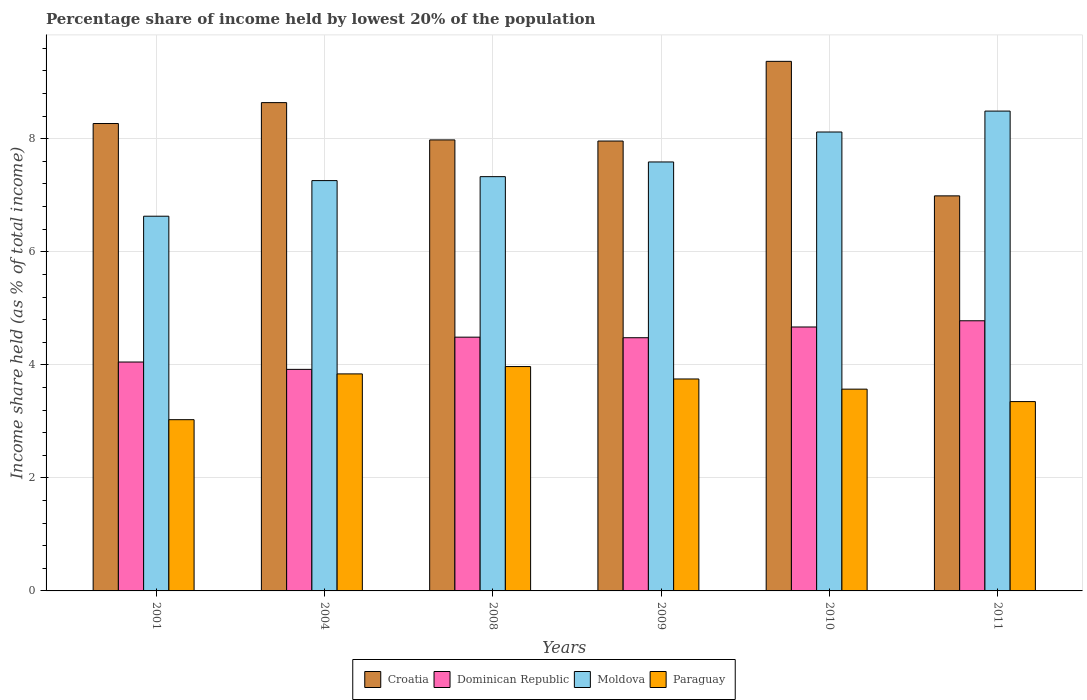How many different coloured bars are there?
Provide a succinct answer. 4. How many groups of bars are there?
Ensure brevity in your answer.  6. Are the number of bars per tick equal to the number of legend labels?
Offer a terse response. Yes. Are the number of bars on each tick of the X-axis equal?
Make the answer very short. Yes. How many bars are there on the 2nd tick from the right?
Keep it short and to the point. 4. In how many cases, is the number of bars for a given year not equal to the number of legend labels?
Your answer should be compact. 0. What is the percentage share of income held by lowest 20% of the population in Moldova in 2010?
Make the answer very short. 8.12. Across all years, what is the maximum percentage share of income held by lowest 20% of the population in Dominican Republic?
Offer a very short reply. 4.78. Across all years, what is the minimum percentage share of income held by lowest 20% of the population in Croatia?
Provide a succinct answer. 6.99. What is the total percentage share of income held by lowest 20% of the population in Moldova in the graph?
Give a very brief answer. 45.42. What is the difference between the percentage share of income held by lowest 20% of the population in Moldova in 2004 and that in 2009?
Provide a succinct answer. -0.33. What is the difference between the percentage share of income held by lowest 20% of the population in Paraguay in 2008 and the percentage share of income held by lowest 20% of the population in Moldova in 2009?
Offer a very short reply. -3.62. What is the average percentage share of income held by lowest 20% of the population in Croatia per year?
Offer a very short reply. 8.2. In the year 2010, what is the difference between the percentage share of income held by lowest 20% of the population in Dominican Republic and percentage share of income held by lowest 20% of the population in Moldova?
Offer a very short reply. -3.45. In how many years, is the percentage share of income held by lowest 20% of the population in Dominican Republic greater than 1.6 %?
Your answer should be compact. 6. What is the ratio of the percentage share of income held by lowest 20% of the population in Dominican Republic in 2009 to that in 2010?
Your answer should be compact. 0.96. What is the difference between the highest and the second highest percentage share of income held by lowest 20% of the population in Croatia?
Your answer should be compact. 0.73. What is the difference between the highest and the lowest percentage share of income held by lowest 20% of the population in Croatia?
Provide a short and direct response. 2.38. Is it the case that in every year, the sum of the percentage share of income held by lowest 20% of the population in Paraguay and percentage share of income held by lowest 20% of the population in Moldova is greater than the sum of percentage share of income held by lowest 20% of the population in Croatia and percentage share of income held by lowest 20% of the population in Dominican Republic?
Provide a short and direct response. No. What does the 3rd bar from the left in 2011 represents?
Make the answer very short. Moldova. What does the 3rd bar from the right in 2010 represents?
Provide a succinct answer. Dominican Republic. How many bars are there?
Make the answer very short. 24. Are the values on the major ticks of Y-axis written in scientific E-notation?
Make the answer very short. No. Does the graph contain any zero values?
Provide a short and direct response. No. Does the graph contain grids?
Your answer should be compact. Yes. Where does the legend appear in the graph?
Make the answer very short. Bottom center. How many legend labels are there?
Offer a terse response. 4. How are the legend labels stacked?
Give a very brief answer. Horizontal. What is the title of the graph?
Your answer should be very brief. Percentage share of income held by lowest 20% of the population. What is the label or title of the X-axis?
Ensure brevity in your answer.  Years. What is the label or title of the Y-axis?
Your answer should be compact. Income share held (as % of total income). What is the Income share held (as % of total income) in Croatia in 2001?
Give a very brief answer. 8.27. What is the Income share held (as % of total income) in Dominican Republic in 2001?
Make the answer very short. 4.05. What is the Income share held (as % of total income) of Moldova in 2001?
Offer a terse response. 6.63. What is the Income share held (as % of total income) of Paraguay in 2001?
Offer a very short reply. 3.03. What is the Income share held (as % of total income) of Croatia in 2004?
Your answer should be very brief. 8.64. What is the Income share held (as % of total income) in Dominican Republic in 2004?
Make the answer very short. 3.92. What is the Income share held (as % of total income) of Moldova in 2004?
Your response must be concise. 7.26. What is the Income share held (as % of total income) of Paraguay in 2004?
Provide a short and direct response. 3.84. What is the Income share held (as % of total income) of Croatia in 2008?
Provide a succinct answer. 7.98. What is the Income share held (as % of total income) of Dominican Republic in 2008?
Provide a succinct answer. 4.49. What is the Income share held (as % of total income) of Moldova in 2008?
Offer a terse response. 7.33. What is the Income share held (as % of total income) of Paraguay in 2008?
Give a very brief answer. 3.97. What is the Income share held (as % of total income) of Croatia in 2009?
Offer a terse response. 7.96. What is the Income share held (as % of total income) of Dominican Republic in 2009?
Ensure brevity in your answer.  4.48. What is the Income share held (as % of total income) of Moldova in 2009?
Your answer should be very brief. 7.59. What is the Income share held (as % of total income) in Paraguay in 2009?
Give a very brief answer. 3.75. What is the Income share held (as % of total income) in Croatia in 2010?
Provide a succinct answer. 9.37. What is the Income share held (as % of total income) of Dominican Republic in 2010?
Ensure brevity in your answer.  4.67. What is the Income share held (as % of total income) of Moldova in 2010?
Offer a terse response. 8.12. What is the Income share held (as % of total income) in Paraguay in 2010?
Give a very brief answer. 3.57. What is the Income share held (as % of total income) in Croatia in 2011?
Your answer should be very brief. 6.99. What is the Income share held (as % of total income) of Dominican Republic in 2011?
Your response must be concise. 4.78. What is the Income share held (as % of total income) of Moldova in 2011?
Your answer should be compact. 8.49. What is the Income share held (as % of total income) of Paraguay in 2011?
Ensure brevity in your answer.  3.35. Across all years, what is the maximum Income share held (as % of total income) in Croatia?
Give a very brief answer. 9.37. Across all years, what is the maximum Income share held (as % of total income) of Dominican Republic?
Give a very brief answer. 4.78. Across all years, what is the maximum Income share held (as % of total income) in Moldova?
Give a very brief answer. 8.49. Across all years, what is the maximum Income share held (as % of total income) in Paraguay?
Ensure brevity in your answer.  3.97. Across all years, what is the minimum Income share held (as % of total income) in Croatia?
Provide a succinct answer. 6.99. Across all years, what is the minimum Income share held (as % of total income) in Dominican Republic?
Keep it short and to the point. 3.92. Across all years, what is the minimum Income share held (as % of total income) in Moldova?
Your answer should be very brief. 6.63. Across all years, what is the minimum Income share held (as % of total income) of Paraguay?
Your answer should be very brief. 3.03. What is the total Income share held (as % of total income) of Croatia in the graph?
Provide a succinct answer. 49.21. What is the total Income share held (as % of total income) of Dominican Republic in the graph?
Provide a succinct answer. 26.39. What is the total Income share held (as % of total income) of Moldova in the graph?
Keep it short and to the point. 45.42. What is the total Income share held (as % of total income) of Paraguay in the graph?
Ensure brevity in your answer.  21.51. What is the difference between the Income share held (as % of total income) of Croatia in 2001 and that in 2004?
Ensure brevity in your answer.  -0.37. What is the difference between the Income share held (as % of total income) of Dominican Republic in 2001 and that in 2004?
Your response must be concise. 0.13. What is the difference between the Income share held (as % of total income) in Moldova in 2001 and that in 2004?
Offer a terse response. -0.63. What is the difference between the Income share held (as % of total income) in Paraguay in 2001 and that in 2004?
Ensure brevity in your answer.  -0.81. What is the difference between the Income share held (as % of total income) of Croatia in 2001 and that in 2008?
Your response must be concise. 0.29. What is the difference between the Income share held (as % of total income) of Dominican Republic in 2001 and that in 2008?
Make the answer very short. -0.44. What is the difference between the Income share held (as % of total income) in Moldova in 2001 and that in 2008?
Provide a short and direct response. -0.7. What is the difference between the Income share held (as % of total income) in Paraguay in 2001 and that in 2008?
Your response must be concise. -0.94. What is the difference between the Income share held (as % of total income) of Croatia in 2001 and that in 2009?
Your answer should be compact. 0.31. What is the difference between the Income share held (as % of total income) of Dominican Republic in 2001 and that in 2009?
Provide a succinct answer. -0.43. What is the difference between the Income share held (as % of total income) of Moldova in 2001 and that in 2009?
Your answer should be very brief. -0.96. What is the difference between the Income share held (as % of total income) of Paraguay in 2001 and that in 2009?
Ensure brevity in your answer.  -0.72. What is the difference between the Income share held (as % of total income) of Croatia in 2001 and that in 2010?
Your answer should be compact. -1.1. What is the difference between the Income share held (as % of total income) of Dominican Republic in 2001 and that in 2010?
Your answer should be compact. -0.62. What is the difference between the Income share held (as % of total income) of Moldova in 2001 and that in 2010?
Offer a very short reply. -1.49. What is the difference between the Income share held (as % of total income) in Paraguay in 2001 and that in 2010?
Give a very brief answer. -0.54. What is the difference between the Income share held (as % of total income) in Croatia in 2001 and that in 2011?
Provide a short and direct response. 1.28. What is the difference between the Income share held (as % of total income) of Dominican Republic in 2001 and that in 2011?
Make the answer very short. -0.73. What is the difference between the Income share held (as % of total income) of Moldova in 2001 and that in 2011?
Your answer should be very brief. -1.86. What is the difference between the Income share held (as % of total income) in Paraguay in 2001 and that in 2011?
Ensure brevity in your answer.  -0.32. What is the difference between the Income share held (as % of total income) of Croatia in 2004 and that in 2008?
Keep it short and to the point. 0.66. What is the difference between the Income share held (as % of total income) of Dominican Republic in 2004 and that in 2008?
Give a very brief answer. -0.57. What is the difference between the Income share held (as % of total income) of Moldova in 2004 and that in 2008?
Make the answer very short. -0.07. What is the difference between the Income share held (as % of total income) of Paraguay in 2004 and that in 2008?
Offer a very short reply. -0.13. What is the difference between the Income share held (as % of total income) of Croatia in 2004 and that in 2009?
Offer a terse response. 0.68. What is the difference between the Income share held (as % of total income) in Dominican Republic in 2004 and that in 2009?
Ensure brevity in your answer.  -0.56. What is the difference between the Income share held (as % of total income) of Moldova in 2004 and that in 2009?
Your response must be concise. -0.33. What is the difference between the Income share held (as % of total income) in Paraguay in 2004 and that in 2009?
Your answer should be compact. 0.09. What is the difference between the Income share held (as % of total income) of Croatia in 2004 and that in 2010?
Give a very brief answer. -0.73. What is the difference between the Income share held (as % of total income) in Dominican Republic in 2004 and that in 2010?
Offer a very short reply. -0.75. What is the difference between the Income share held (as % of total income) in Moldova in 2004 and that in 2010?
Your answer should be compact. -0.86. What is the difference between the Income share held (as % of total income) in Paraguay in 2004 and that in 2010?
Offer a terse response. 0.27. What is the difference between the Income share held (as % of total income) in Croatia in 2004 and that in 2011?
Keep it short and to the point. 1.65. What is the difference between the Income share held (as % of total income) of Dominican Republic in 2004 and that in 2011?
Make the answer very short. -0.86. What is the difference between the Income share held (as % of total income) of Moldova in 2004 and that in 2011?
Make the answer very short. -1.23. What is the difference between the Income share held (as % of total income) in Paraguay in 2004 and that in 2011?
Ensure brevity in your answer.  0.49. What is the difference between the Income share held (as % of total income) in Dominican Republic in 2008 and that in 2009?
Ensure brevity in your answer.  0.01. What is the difference between the Income share held (as % of total income) of Moldova in 2008 and that in 2009?
Your response must be concise. -0.26. What is the difference between the Income share held (as % of total income) in Paraguay in 2008 and that in 2009?
Ensure brevity in your answer.  0.22. What is the difference between the Income share held (as % of total income) in Croatia in 2008 and that in 2010?
Offer a very short reply. -1.39. What is the difference between the Income share held (as % of total income) in Dominican Republic in 2008 and that in 2010?
Your response must be concise. -0.18. What is the difference between the Income share held (as % of total income) of Moldova in 2008 and that in 2010?
Your answer should be compact. -0.79. What is the difference between the Income share held (as % of total income) of Paraguay in 2008 and that in 2010?
Offer a very short reply. 0.4. What is the difference between the Income share held (as % of total income) of Croatia in 2008 and that in 2011?
Your response must be concise. 0.99. What is the difference between the Income share held (as % of total income) of Dominican Republic in 2008 and that in 2011?
Provide a succinct answer. -0.29. What is the difference between the Income share held (as % of total income) in Moldova in 2008 and that in 2011?
Offer a very short reply. -1.16. What is the difference between the Income share held (as % of total income) of Paraguay in 2008 and that in 2011?
Make the answer very short. 0.62. What is the difference between the Income share held (as % of total income) of Croatia in 2009 and that in 2010?
Ensure brevity in your answer.  -1.41. What is the difference between the Income share held (as % of total income) in Dominican Republic in 2009 and that in 2010?
Keep it short and to the point. -0.19. What is the difference between the Income share held (as % of total income) in Moldova in 2009 and that in 2010?
Make the answer very short. -0.53. What is the difference between the Income share held (as % of total income) in Paraguay in 2009 and that in 2010?
Provide a short and direct response. 0.18. What is the difference between the Income share held (as % of total income) in Croatia in 2009 and that in 2011?
Keep it short and to the point. 0.97. What is the difference between the Income share held (as % of total income) of Dominican Republic in 2009 and that in 2011?
Ensure brevity in your answer.  -0.3. What is the difference between the Income share held (as % of total income) of Croatia in 2010 and that in 2011?
Your answer should be very brief. 2.38. What is the difference between the Income share held (as % of total income) of Dominican Republic in 2010 and that in 2011?
Your answer should be compact. -0.11. What is the difference between the Income share held (as % of total income) of Moldova in 2010 and that in 2011?
Give a very brief answer. -0.37. What is the difference between the Income share held (as % of total income) of Paraguay in 2010 and that in 2011?
Provide a succinct answer. 0.22. What is the difference between the Income share held (as % of total income) in Croatia in 2001 and the Income share held (as % of total income) in Dominican Republic in 2004?
Provide a succinct answer. 4.35. What is the difference between the Income share held (as % of total income) of Croatia in 2001 and the Income share held (as % of total income) of Moldova in 2004?
Offer a very short reply. 1.01. What is the difference between the Income share held (as % of total income) of Croatia in 2001 and the Income share held (as % of total income) of Paraguay in 2004?
Provide a short and direct response. 4.43. What is the difference between the Income share held (as % of total income) of Dominican Republic in 2001 and the Income share held (as % of total income) of Moldova in 2004?
Ensure brevity in your answer.  -3.21. What is the difference between the Income share held (as % of total income) of Dominican Republic in 2001 and the Income share held (as % of total income) of Paraguay in 2004?
Provide a short and direct response. 0.21. What is the difference between the Income share held (as % of total income) in Moldova in 2001 and the Income share held (as % of total income) in Paraguay in 2004?
Ensure brevity in your answer.  2.79. What is the difference between the Income share held (as % of total income) of Croatia in 2001 and the Income share held (as % of total income) of Dominican Republic in 2008?
Provide a succinct answer. 3.78. What is the difference between the Income share held (as % of total income) in Croatia in 2001 and the Income share held (as % of total income) in Paraguay in 2008?
Ensure brevity in your answer.  4.3. What is the difference between the Income share held (as % of total income) of Dominican Republic in 2001 and the Income share held (as % of total income) of Moldova in 2008?
Make the answer very short. -3.28. What is the difference between the Income share held (as % of total income) in Moldova in 2001 and the Income share held (as % of total income) in Paraguay in 2008?
Ensure brevity in your answer.  2.66. What is the difference between the Income share held (as % of total income) in Croatia in 2001 and the Income share held (as % of total income) in Dominican Republic in 2009?
Provide a succinct answer. 3.79. What is the difference between the Income share held (as % of total income) of Croatia in 2001 and the Income share held (as % of total income) of Moldova in 2009?
Your answer should be compact. 0.68. What is the difference between the Income share held (as % of total income) in Croatia in 2001 and the Income share held (as % of total income) in Paraguay in 2009?
Offer a very short reply. 4.52. What is the difference between the Income share held (as % of total income) in Dominican Republic in 2001 and the Income share held (as % of total income) in Moldova in 2009?
Your response must be concise. -3.54. What is the difference between the Income share held (as % of total income) of Dominican Republic in 2001 and the Income share held (as % of total income) of Paraguay in 2009?
Keep it short and to the point. 0.3. What is the difference between the Income share held (as % of total income) of Moldova in 2001 and the Income share held (as % of total income) of Paraguay in 2009?
Your answer should be compact. 2.88. What is the difference between the Income share held (as % of total income) of Dominican Republic in 2001 and the Income share held (as % of total income) of Moldova in 2010?
Ensure brevity in your answer.  -4.07. What is the difference between the Income share held (as % of total income) of Dominican Republic in 2001 and the Income share held (as % of total income) of Paraguay in 2010?
Give a very brief answer. 0.48. What is the difference between the Income share held (as % of total income) of Moldova in 2001 and the Income share held (as % of total income) of Paraguay in 2010?
Offer a terse response. 3.06. What is the difference between the Income share held (as % of total income) of Croatia in 2001 and the Income share held (as % of total income) of Dominican Republic in 2011?
Your answer should be very brief. 3.49. What is the difference between the Income share held (as % of total income) in Croatia in 2001 and the Income share held (as % of total income) in Moldova in 2011?
Give a very brief answer. -0.22. What is the difference between the Income share held (as % of total income) in Croatia in 2001 and the Income share held (as % of total income) in Paraguay in 2011?
Provide a succinct answer. 4.92. What is the difference between the Income share held (as % of total income) in Dominican Republic in 2001 and the Income share held (as % of total income) in Moldova in 2011?
Keep it short and to the point. -4.44. What is the difference between the Income share held (as % of total income) of Moldova in 2001 and the Income share held (as % of total income) of Paraguay in 2011?
Your answer should be very brief. 3.28. What is the difference between the Income share held (as % of total income) in Croatia in 2004 and the Income share held (as % of total income) in Dominican Republic in 2008?
Keep it short and to the point. 4.15. What is the difference between the Income share held (as % of total income) of Croatia in 2004 and the Income share held (as % of total income) of Moldova in 2008?
Your answer should be very brief. 1.31. What is the difference between the Income share held (as % of total income) in Croatia in 2004 and the Income share held (as % of total income) in Paraguay in 2008?
Your answer should be compact. 4.67. What is the difference between the Income share held (as % of total income) of Dominican Republic in 2004 and the Income share held (as % of total income) of Moldova in 2008?
Offer a very short reply. -3.41. What is the difference between the Income share held (as % of total income) in Dominican Republic in 2004 and the Income share held (as % of total income) in Paraguay in 2008?
Provide a short and direct response. -0.05. What is the difference between the Income share held (as % of total income) in Moldova in 2004 and the Income share held (as % of total income) in Paraguay in 2008?
Provide a succinct answer. 3.29. What is the difference between the Income share held (as % of total income) of Croatia in 2004 and the Income share held (as % of total income) of Dominican Republic in 2009?
Keep it short and to the point. 4.16. What is the difference between the Income share held (as % of total income) of Croatia in 2004 and the Income share held (as % of total income) of Moldova in 2009?
Make the answer very short. 1.05. What is the difference between the Income share held (as % of total income) in Croatia in 2004 and the Income share held (as % of total income) in Paraguay in 2009?
Ensure brevity in your answer.  4.89. What is the difference between the Income share held (as % of total income) of Dominican Republic in 2004 and the Income share held (as % of total income) of Moldova in 2009?
Offer a very short reply. -3.67. What is the difference between the Income share held (as % of total income) of Dominican Republic in 2004 and the Income share held (as % of total income) of Paraguay in 2009?
Make the answer very short. 0.17. What is the difference between the Income share held (as % of total income) in Moldova in 2004 and the Income share held (as % of total income) in Paraguay in 2009?
Ensure brevity in your answer.  3.51. What is the difference between the Income share held (as % of total income) of Croatia in 2004 and the Income share held (as % of total income) of Dominican Republic in 2010?
Give a very brief answer. 3.97. What is the difference between the Income share held (as % of total income) of Croatia in 2004 and the Income share held (as % of total income) of Moldova in 2010?
Your answer should be compact. 0.52. What is the difference between the Income share held (as % of total income) of Croatia in 2004 and the Income share held (as % of total income) of Paraguay in 2010?
Your response must be concise. 5.07. What is the difference between the Income share held (as % of total income) of Dominican Republic in 2004 and the Income share held (as % of total income) of Moldova in 2010?
Offer a very short reply. -4.2. What is the difference between the Income share held (as % of total income) of Moldova in 2004 and the Income share held (as % of total income) of Paraguay in 2010?
Give a very brief answer. 3.69. What is the difference between the Income share held (as % of total income) in Croatia in 2004 and the Income share held (as % of total income) in Dominican Republic in 2011?
Your answer should be compact. 3.86. What is the difference between the Income share held (as % of total income) in Croatia in 2004 and the Income share held (as % of total income) in Paraguay in 2011?
Your answer should be compact. 5.29. What is the difference between the Income share held (as % of total income) in Dominican Republic in 2004 and the Income share held (as % of total income) in Moldova in 2011?
Give a very brief answer. -4.57. What is the difference between the Income share held (as % of total income) in Dominican Republic in 2004 and the Income share held (as % of total income) in Paraguay in 2011?
Make the answer very short. 0.57. What is the difference between the Income share held (as % of total income) in Moldova in 2004 and the Income share held (as % of total income) in Paraguay in 2011?
Provide a short and direct response. 3.91. What is the difference between the Income share held (as % of total income) in Croatia in 2008 and the Income share held (as % of total income) in Dominican Republic in 2009?
Provide a succinct answer. 3.5. What is the difference between the Income share held (as % of total income) of Croatia in 2008 and the Income share held (as % of total income) of Moldova in 2009?
Your answer should be compact. 0.39. What is the difference between the Income share held (as % of total income) of Croatia in 2008 and the Income share held (as % of total income) of Paraguay in 2009?
Make the answer very short. 4.23. What is the difference between the Income share held (as % of total income) of Dominican Republic in 2008 and the Income share held (as % of total income) of Paraguay in 2009?
Make the answer very short. 0.74. What is the difference between the Income share held (as % of total income) in Moldova in 2008 and the Income share held (as % of total income) in Paraguay in 2009?
Offer a terse response. 3.58. What is the difference between the Income share held (as % of total income) of Croatia in 2008 and the Income share held (as % of total income) of Dominican Republic in 2010?
Keep it short and to the point. 3.31. What is the difference between the Income share held (as % of total income) in Croatia in 2008 and the Income share held (as % of total income) in Moldova in 2010?
Make the answer very short. -0.14. What is the difference between the Income share held (as % of total income) in Croatia in 2008 and the Income share held (as % of total income) in Paraguay in 2010?
Make the answer very short. 4.41. What is the difference between the Income share held (as % of total income) of Dominican Republic in 2008 and the Income share held (as % of total income) of Moldova in 2010?
Offer a very short reply. -3.63. What is the difference between the Income share held (as % of total income) in Moldova in 2008 and the Income share held (as % of total income) in Paraguay in 2010?
Make the answer very short. 3.76. What is the difference between the Income share held (as % of total income) of Croatia in 2008 and the Income share held (as % of total income) of Dominican Republic in 2011?
Offer a very short reply. 3.2. What is the difference between the Income share held (as % of total income) in Croatia in 2008 and the Income share held (as % of total income) in Moldova in 2011?
Make the answer very short. -0.51. What is the difference between the Income share held (as % of total income) in Croatia in 2008 and the Income share held (as % of total income) in Paraguay in 2011?
Your response must be concise. 4.63. What is the difference between the Income share held (as % of total income) of Dominican Republic in 2008 and the Income share held (as % of total income) of Paraguay in 2011?
Make the answer very short. 1.14. What is the difference between the Income share held (as % of total income) of Moldova in 2008 and the Income share held (as % of total income) of Paraguay in 2011?
Provide a succinct answer. 3.98. What is the difference between the Income share held (as % of total income) in Croatia in 2009 and the Income share held (as % of total income) in Dominican Republic in 2010?
Your answer should be very brief. 3.29. What is the difference between the Income share held (as % of total income) in Croatia in 2009 and the Income share held (as % of total income) in Moldova in 2010?
Your response must be concise. -0.16. What is the difference between the Income share held (as % of total income) of Croatia in 2009 and the Income share held (as % of total income) of Paraguay in 2010?
Your answer should be very brief. 4.39. What is the difference between the Income share held (as % of total income) in Dominican Republic in 2009 and the Income share held (as % of total income) in Moldova in 2010?
Make the answer very short. -3.64. What is the difference between the Income share held (as % of total income) in Dominican Republic in 2009 and the Income share held (as % of total income) in Paraguay in 2010?
Keep it short and to the point. 0.91. What is the difference between the Income share held (as % of total income) in Moldova in 2009 and the Income share held (as % of total income) in Paraguay in 2010?
Offer a terse response. 4.02. What is the difference between the Income share held (as % of total income) in Croatia in 2009 and the Income share held (as % of total income) in Dominican Republic in 2011?
Your answer should be compact. 3.18. What is the difference between the Income share held (as % of total income) of Croatia in 2009 and the Income share held (as % of total income) of Moldova in 2011?
Offer a very short reply. -0.53. What is the difference between the Income share held (as % of total income) of Croatia in 2009 and the Income share held (as % of total income) of Paraguay in 2011?
Your answer should be compact. 4.61. What is the difference between the Income share held (as % of total income) in Dominican Republic in 2009 and the Income share held (as % of total income) in Moldova in 2011?
Make the answer very short. -4.01. What is the difference between the Income share held (as % of total income) in Dominican Republic in 2009 and the Income share held (as % of total income) in Paraguay in 2011?
Provide a succinct answer. 1.13. What is the difference between the Income share held (as % of total income) of Moldova in 2009 and the Income share held (as % of total income) of Paraguay in 2011?
Give a very brief answer. 4.24. What is the difference between the Income share held (as % of total income) in Croatia in 2010 and the Income share held (as % of total income) in Dominican Republic in 2011?
Offer a very short reply. 4.59. What is the difference between the Income share held (as % of total income) in Croatia in 2010 and the Income share held (as % of total income) in Moldova in 2011?
Provide a short and direct response. 0.88. What is the difference between the Income share held (as % of total income) of Croatia in 2010 and the Income share held (as % of total income) of Paraguay in 2011?
Keep it short and to the point. 6.02. What is the difference between the Income share held (as % of total income) of Dominican Republic in 2010 and the Income share held (as % of total income) of Moldova in 2011?
Provide a short and direct response. -3.82. What is the difference between the Income share held (as % of total income) of Dominican Republic in 2010 and the Income share held (as % of total income) of Paraguay in 2011?
Offer a terse response. 1.32. What is the difference between the Income share held (as % of total income) of Moldova in 2010 and the Income share held (as % of total income) of Paraguay in 2011?
Offer a very short reply. 4.77. What is the average Income share held (as % of total income) of Croatia per year?
Keep it short and to the point. 8.2. What is the average Income share held (as % of total income) in Dominican Republic per year?
Ensure brevity in your answer.  4.4. What is the average Income share held (as % of total income) of Moldova per year?
Offer a terse response. 7.57. What is the average Income share held (as % of total income) in Paraguay per year?
Make the answer very short. 3.58. In the year 2001, what is the difference between the Income share held (as % of total income) in Croatia and Income share held (as % of total income) in Dominican Republic?
Make the answer very short. 4.22. In the year 2001, what is the difference between the Income share held (as % of total income) of Croatia and Income share held (as % of total income) of Moldova?
Keep it short and to the point. 1.64. In the year 2001, what is the difference between the Income share held (as % of total income) of Croatia and Income share held (as % of total income) of Paraguay?
Offer a very short reply. 5.24. In the year 2001, what is the difference between the Income share held (as % of total income) of Dominican Republic and Income share held (as % of total income) of Moldova?
Your response must be concise. -2.58. In the year 2001, what is the difference between the Income share held (as % of total income) in Dominican Republic and Income share held (as % of total income) in Paraguay?
Provide a succinct answer. 1.02. In the year 2001, what is the difference between the Income share held (as % of total income) in Moldova and Income share held (as % of total income) in Paraguay?
Provide a succinct answer. 3.6. In the year 2004, what is the difference between the Income share held (as % of total income) of Croatia and Income share held (as % of total income) of Dominican Republic?
Keep it short and to the point. 4.72. In the year 2004, what is the difference between the Income share held (as % of total income) in Croatia and Income share held (as % of total income) in Moldova?
Provide a short and direct response. 1.38. In the year 2004, what is the difference between the Income share held (as % of total income) of Dominican Republic and Income share held (as % of total income) of Moldova?
Keep it short and to the point. -3.34. In the year 2004, what is the difference between the Income share held (as % of total income) of Dominican Republic and Income share held (as % of total income) of Paraguay?
Offer a terse response. 0.08. In the year 2004, what is the difference between the Income share held (as % of total income) in Moldova and Income share held (as % of total income) in Paraguay?
Your answer should be compact. 3.42. In the year 2008, what is the difference between the Income share held (as % of total income) in Croatia and Income share held (as % of total income) in Dominican Republic?
Offer a terse response. 3.49. In the year 2008, what is the difference between the Income share held (as % of total income) in Croatia and Income share held (as % of total income) in Moldova?
Ensure brevity in your answer.  0.65. In the year 2008, what is the difference between the Income share held (as % of total income) in Croatia and Income share held (as % of total income) in Paraguay?
Ensure brevity in your answer.  4.01. In the year 2008, what is the difference between the Income share held (as % of total income) of Dominican Republic and Income share held (as % of total income) of Moldova?
Offer a very short reply. -2.84. In the year 2008, what is the difference between the Income share held (as % of total income) of Dominican Republic and Income share held (as % of total income) of Paraguay?
Provide a short and direct response. 0.52. In the year 2008, what is the difference between the Income share held (as % of total income) in Moldova and Income share held (as % of total income) in Paraguay?
Make the answer very short. 3.36. In the year 2009, what is the difference between the Income share held (as % of total income) in Croatia and Income share held (as % of total income) in Dominican Republic?
Offer a very short reply. 3.48. In the year 2009, what is the difference between the Income share held (as % of total income) of Croatia and Income share held (as % of total income) of Moldova?
Your answer should be compact. 0.37. In the year 2009, what is the difference between the Income share held (as % of total income) of Croatia and Income share held (as % of total income) of Paraguay?
Offer a terse response. 4.21. In the year 2009, what is the difference between the Income share held (as % of total income) of Dominican Republic and Income share held (as % of total income) of Moldova?
Provide a succinct answer. -3.11. In the year 2009, what is the difference between the Income share held (as % of total income) of Dominican Republic and Income share held (as % of total income) of Paraguay?
Your response must be concise. 0.73. In the year 2009, what is the difference between the Income share held (as % of total income) in Moldova and Income share held (as % of total income) in Paraguay?
Offer a terse response. 3.84. In the year 2010, what is the difference between the Income share held (as % of total income) of Croatia and Income share held (as % of total income) of Dominican Republic?
Provide a succinct answer. 4.7. In the year 2010, what is the difference between the Income share held (as % of total income) in Croatia and Income share held (as % of total income) in Moldova?
Your answer should be compact. 1.25. In the year 2010, what is the difference between the Income share held (as % of total income) of Croatia and Income share held (as % of total income) of Paraguay?
Ensure brevity in your answer.  5.8. In the year 2010, what is the difference between the Income share held (as % of total income) of Dominican Republic and Income share held (as % of total income) of Moldova?
Keep it short and to the point. -3.45. In the year 2010, what is the difference between the Income share held (as % of total income) of Dominican Republic and Income share held (as % of total income) of Paraguay?
Make the answer very short. 1.1. In the year 2010, what is the difference between the Income share held (as % of total income) of Moldova and Income share held (as % of total income) of Paraguay?
Give a very brief answer. 4.55. In the year 2011, what is the difference between the Income share held (as % of total income) in Croatia and Income share held (as % of total income) in Dominican Republic?
Keep it short and to the point. 2.21. In the year 2011, what is the difference between the Income share held (as % of total income) in Croatia and Income share held (as % of total income) in Moldova?
Make the answer very short. -1.5. In the year 2011, what is the difference between the Income share held (as % of total income) in Croatia and Income share held (as % of total income) in Paraguay?
Offer a terse response. 3.64. In the year 2011, what is the difference between the Income share held (as % of total income) of Dominican Republic and Income share held (as % of total income) of Moldova?
Your answer should be compact. -3.71. In the year 2011, what is the difference between the Income share held (as % of total income) of Dominican Republic and Income share held (as % of total income) of Paraguay?
Provide a succinct answer. 1.43. In the year 2011, what is the difference between the Income share held (as % of total income) in Moldova and Income share held (as % of total income) in Paraguay?
Make the answer very short. 5.14. What is the ratio of the Income share held (as % of total income) in Croatia in 2001 to that in 2004?
Give a very brief answer. 0.96. What is the ratio of the Income share held (as % of total income) in Dominican Republic in 2001 to that in 2004?
Your answer should be very brief. 1.03. What is the ratio of the Income share held (as % of total income) of Moldova in 2001 to that in 2004?
Your answer should be compact. 0.91. What is the ratio of the Income share held (as % of total income) of Paraguay in 2001 to that in 2004?
Keep it short and to the point. 0.79. What is the ratio of the Income share held (as % of total income) in Croatia in 2001 to that in 2008?
Make the answer very short. 1.04. What is the ratio of the Income share held (as % of total income) of Dominican Republic in 2001 to that in 2008?
Your answer should be very brief. 0.9. What is the ratio of the Income share held (as % of total income) in Moldova in 2001 to that in 2008?
Keep it short and to the point. 0.9. What is the ratio of the Income share held (as % of total income) of Paraguay in 2001 to that in 2008?
Your response must be concise. 0.76. What is the ratio of the Income share held (as % of total income) in Croatia in 2001 to that in 2009?
Make the answer very short. 1.04. What is the ratio of the Income share held (as % of total income) in Dominican Republic in 2001 to that in 2009?
Your answer should be very brief. 0.9. What is the ratio of the Income share held (as % of total income) in Moldova in 2001 to that in 2009?
Your answer should be compact. 0.87. What is the ratio of the Income share held (as % of total income) in Paraguay in 2001 to that in 2009?
Your answer should be compact. 0.81. What is the ratio of the Income share held (as % of total income) of Croatia in 2001 to that in 2010?
Provide a succinct answer. 0.88. What is the ratio of the Income share held (as % of total income) in Dominican Republic in 2001 to that in 2010?
Provide a short and direct response. 0.87. What is the ratio of the Income share held (as % of total income) of Moldova in 2001 to that in 2010?
Provide a short and direct response. 0.82. What is the ratio of the Income share held (as % of total income) in Paraguay in 2001 to that in 2010?
Your answer should be very brief. 0.85. What is the ratio of the Income share held (as % of total income) in Croatia in 2001 to that in 2011?
Make the answer very short. 1.18. What is the ratio of the Income share held (as % of total income) in Dominican Republic in 2001 to that in 2011?
Give a very brief answer. 0.85. What is the ratio of the Income share held (as % of total income) in Moldova in 2001 to that in 2011?
Offer a very short reply. 0.78. What is the ratio of the Income share held (as % of total income) of Paraguay in 2001 to that in 2011?
Offer a terse response. 0.9. What is the ratio of the Income share held (as % of total income) in Croatia in 2004 to that in 2008?
Provide a short and direct response. 1.08. What is the ratio of the Income share held (as % of total income) of Dominican Republic in 2004 to that in 2008?
Provide a succinct answer. 0.87. What is the ratio of the Income share held (as % of total income) of Moldova in 2004 to that in 2008?
Your response must be concise. 0.99. What is the ratio of the Income share held (as % of total income) of Paraguay in 2004 to that in 2008?
Ensure brevity in your answer.  0.97. What is the ratio of the Income share held (as % of total income) in Croatia in 2004 to that in 2009?
Your answer should be compact. 1.09. What is the ratio of the Income share held (as % of total income) in Moldova in 2004 to that in 2009?
Offer a very short reply. 0.96. What is the ratio of the Income share held (as % of total income) in Croatia in 2004 to that in 2010?
Your response must be concise. 0.92. What is the ratio of the Income share held (as % of total income) of Dominican Republic in 2004 to that in 2010?
Make the answer very short. 0.84. What is the ratio of the Income share held (as % of total income) in Moldova in 2004 to that in 2010?
Keep it short and to the point. 0.89. What is the ratio of the Income share held (as % of total income) of Paraguay in 2004 to that in 2010?
Provide a succinct answer. 1.08. What is the ratio of the Income share held (as % of total income) in Croatia in 2004 to that in 2011?
Make the answer very short. 1.24. What is the ratio of the Income share held (as % of total income) of Dominican Republic in 2004 to that in 2011?
Ensure brevity in your answer.  0.82. What is the ratio of the Income share held (as % of total income) in Moldova in 2004 to that in 2011?
Give a very brief answer. 0.86. What is the ratio of the Income share held (as % of total income) in Paraguay in 2004 to that in 2011?
Give a very brief answer. 1.15. What is the ratio of the Income share held (as % of total income) of Croatia in 2008 to that in 2009?
Offer a terse response. 1. What is the ratio of the Income share held (as % of total income) in Dominican Republic in 2008 to that in 2009?
Your response must be concise. 1. What is the ratio of the Income share held (as % of total income) in Moldova in 2008 to that in 2009?
Provide a short and direct response. 0.97. What is the ratio of the Income share held (as % of total income) of Paraguay in 2008 to that in 2009?
Ensure brevity in your answer.  1.06. What is the ratio of the Income share held (as % of total income) in Croatia in 2008 to that in 2010?
Keep it short and to the point. 0.85. What is the ratio of the Income share held (as % of total income) in Dominican Republic in 2008 to that in 2010?
Keep it short and to the point. 0.96. What is the ratio of the Income share held (as % of total income) in Moldova in 2008 to that in 2010?
Ensure brevity in your answer.  0.9. What is the ratio of the Income share held (as % of total income) in Paraguay in 2008 to that in 2010?
Make the answer very short. 1.11. What is the ratio of the Income share held (as % of total income) in Croatia in 2008 to that in 2011?
Make the answer very short. 1.14. What is the ratio of the Income share held (as % of total income) in Dominican Republic in 2008 to that in 2011?
Offer a terse response. 0.94. What is the ratio of the Income share held (as % of total income) of Moldova in 2008 to that in 2011?
Make the answer very short. 0.86. What is the ratio of the Income share held (as % of total income) of Paraguay in 2008 to that in 2011?
Make the answer very short. 1.19. What is the ratio of the Income share held (as % of total income) of Croatia in 2009 to that in 2010?
Offer a terse response. 0.85. What is the ratio of the Income share held (as % of total income) in Dominican Republic in 2009 to that in 2010?
Make the answer very short. 0.96. What is the ratio of the Income share held (as % of total income) in Moldova in 2009 to that in 2010?
Your answer should be compact. 0.93. What is the ratio of the Income share held (as % of total income) of Paraguay in 2009 to that in 2010?
Your answer should be very brief. 1.05. What is the ratio of the Income share held (as % of total income) of Croatia in 2009 to that in 2011?
Keep it short and to the point. 1.14. What is the ratio of the Income share held (as % of total income) of Dominican Republic in 2009 to that in 2011?
Provide a succinct answer. 0.94. What is the ratio of the Income share held (as % of total income) in Moldova in 2009 to that in 2011?
Make the answer very short. 0.89. What is the ratio of the Income share held (as % of total income) in Paraguay in 2009 to that in 2011?
Your response must be concise. 1.12. What is the ratio of the Income share held (as % of total income) of Croatia in 2010 to that in 2011?
Ensure brevity in your answer.  1.34. What is the ratio of the Income share held (as % of total income) of Moldova in 2010 to that in 2011?
Keep it short and to the point. 0.96. What is the ratio of the Income share held (as % of total income) of Paraguay in 2010 to that in 2011?
Provide a succinct answer. 1.07. What is the difference between the highest and the second highest Income share held (as % of total income) of Croatia?
Your response must be concise. 0.73. What is the difference between the highest and the second highest Income share held (as % of total income) in Dominican Republic?
Offer a terse response. 0.11. What is the difference between the highest and the second highest Income share held (as % of total income) of Moldova?
Offer a terse response. 0.37. What is the difference between the highest and the second highest Income share held (as % of total income) in Paraguay?
Ensure brevity in your answer.  0.13. What is the difference between the highest and the lowest Income share held (as % of total income) of Croatia?
Keep it short and to the point. 2.38. What is the difference between the highest and the lowest Income share held (as % of total income) in Dominican Republic?
Keep it short and to the point. 0.86. What is the difference between the highest and the lowest Income share held (as % of total income) in Moldova?
Your answer should be compact. 1.86. 